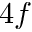<formula> <loc_0><loc_0><loc_500><loc_500>4 f</formula> 